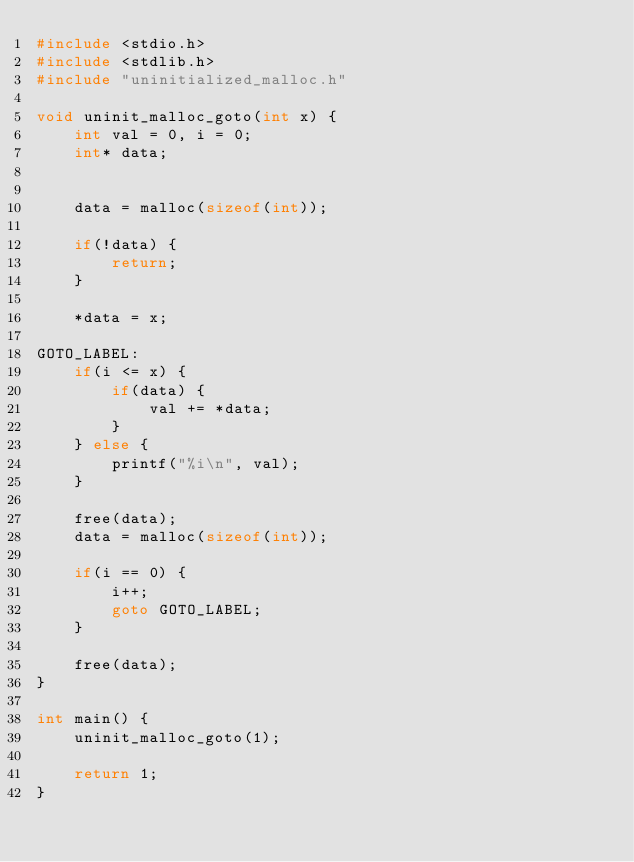Convert code to text. <code><loc_0><loc_0><loc_500><loc_500><_C_>#include <stdio.h>
#include <stdlib.h>
#include "uninitialized_malloc.h"

void uninit_malloc_goto(int x) {
    int val = 0, i = 0;
    int* data;


    data = malloc(sizeof(int));

    if(!data) {
        return;
    }

    *data = x;

GOTO_LABEL:
    if(i <= x) {
        if(data) {
            val += *data;
        }
    } else {
        printf("%i\n", val);
    }

    free(data);
    data = malloc(sizeof(int));

    if(i == 0) {
        i++;
        goto GOTO_LABEL;
    }

    free(data);
}

int main() {
    uninit_malloc_goto(1);

    return 1;
}
</code> 